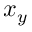Convert formula to latex. <formula><loc_0><loc_0><loc_500><loc_500>x _ { y }</formula> 